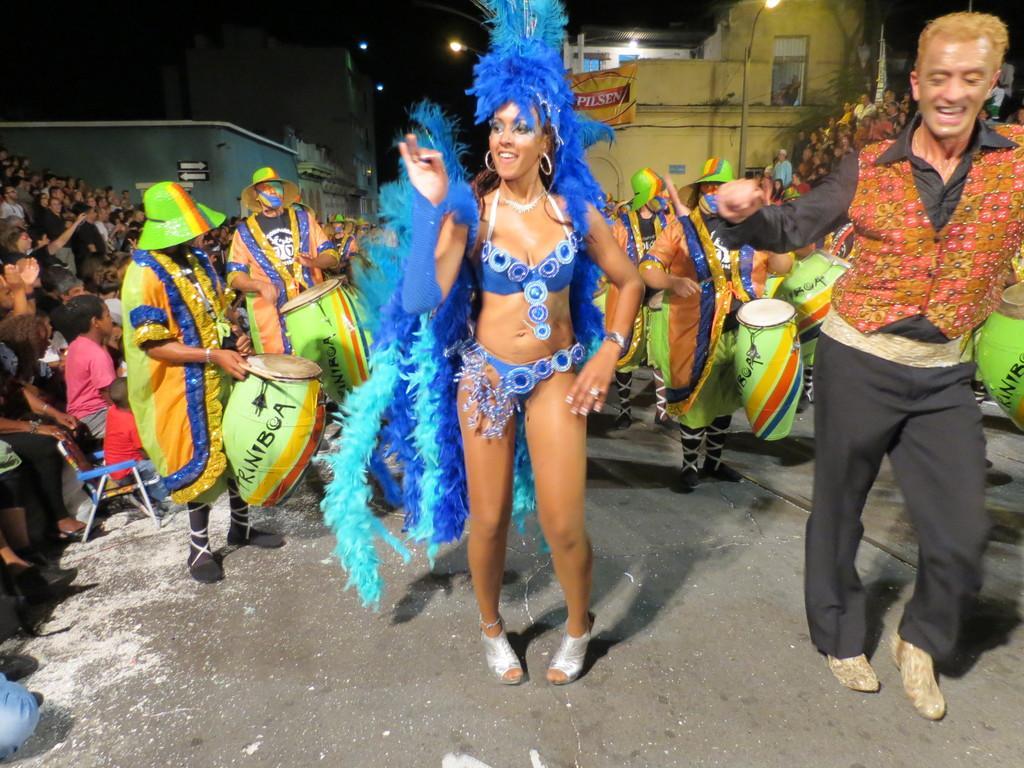Could you give a brief overview of what you see in this image? On the right side, we can see audience sitting and watching a dance show. In the middle of the image we can see two persons are playing drums and dressed in a different manner. A lady is dancing and she wore a blue color dress. On the left side of the image we can see a person is dancing and he wore a black color dress and a coat, behind him a building and some audience are there. 